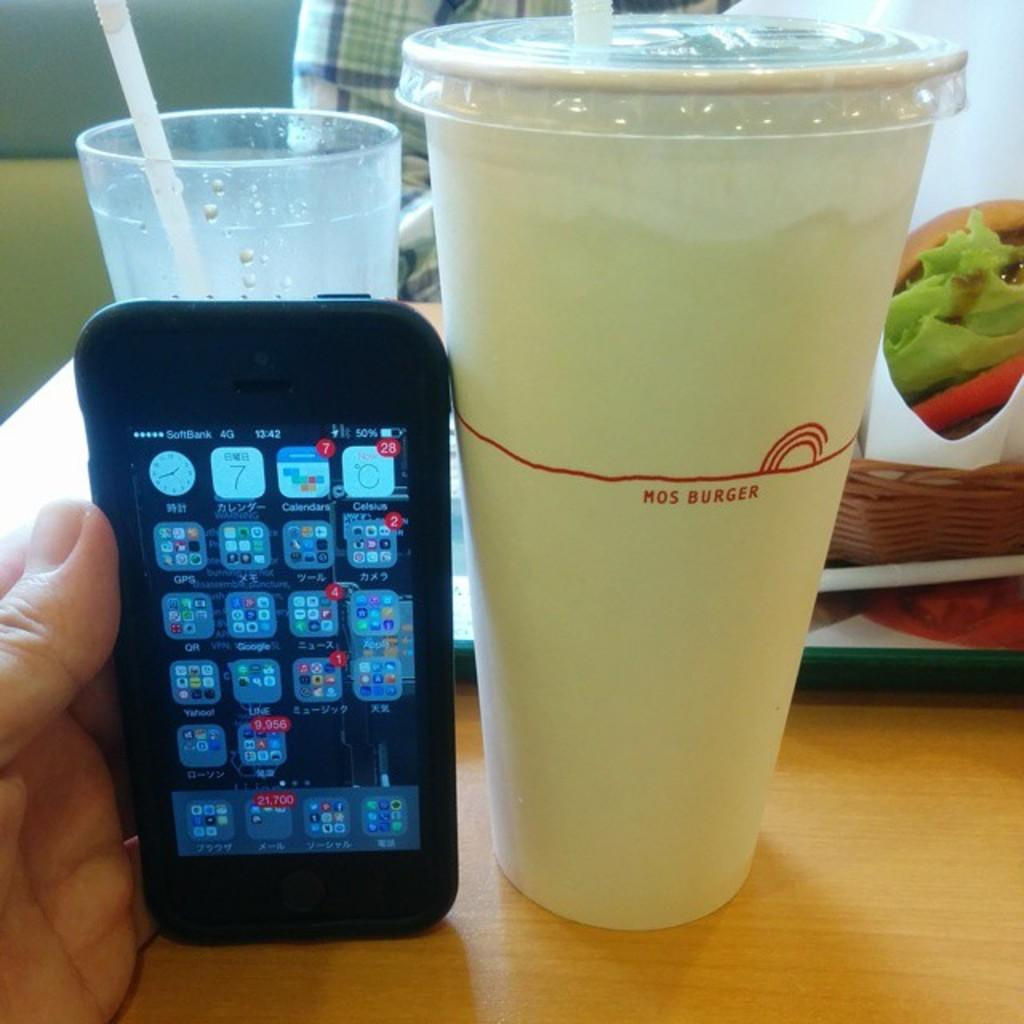<image>
Summarize the visual content of the image. A phone is in someone's hand with a beverage cup next to it that says MOS BURGER. 